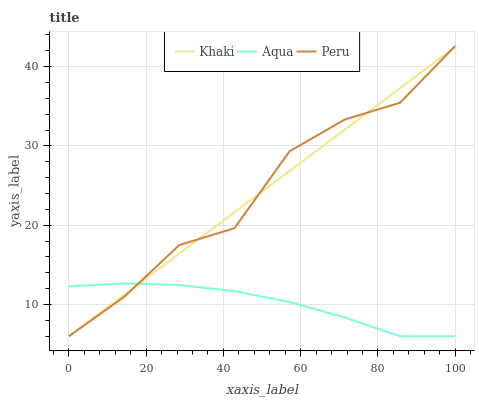Does Peru have the minimum area under the curve?
Answer yes or no. No. Does Aqua have the maximum area under the curve?
Answer yes or no. No. Is Aqua the smoothest?
Answer yes or no. No. Is Aqua the roughest?
Answer yes or no. No. Does Aqua have the highest value?
Answer yes or no. No. 